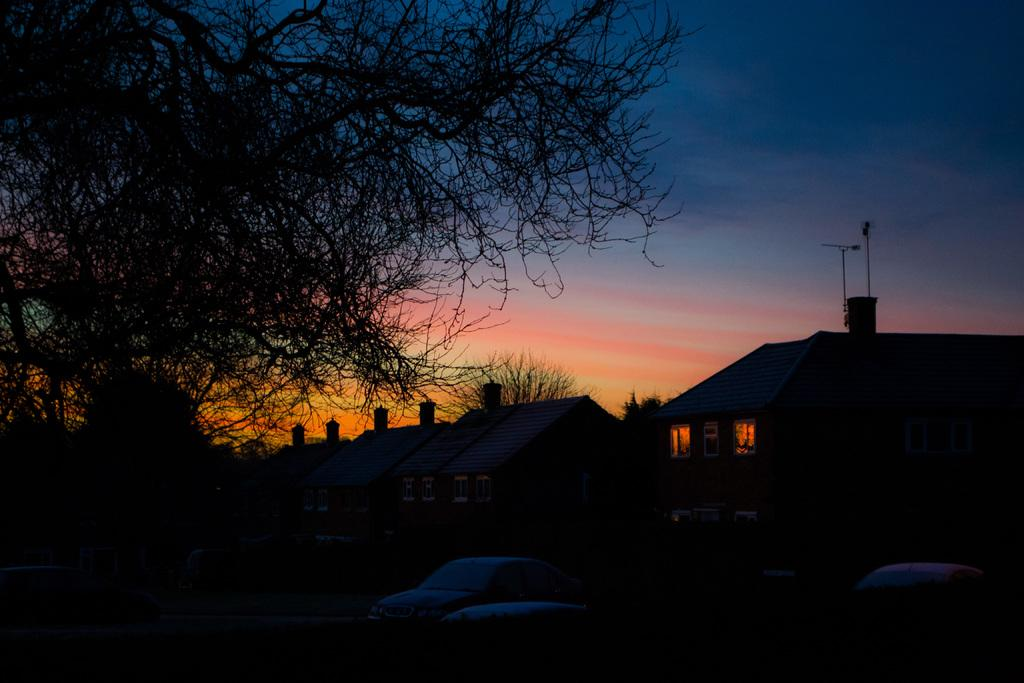At what time of day was the image taken? The image was taken during night time. What type of structures can be seen in the image? There are houses in the image. What natural elements are present in the image? There are trees in the image. What mode of transportation is visible in the image? There is a car in the image. What part of the sky is visible in the image? The sky is visible in the image. What man-made object can be seen in the image besides the houses and car? There is a pole in the image. What type of holiday is being celebrated in the image? There is no indication of a holiday being celebrated in the image. Can you hear a whistle in the image? There is no sound present in the image, so it is not possible to hear a whistle. 